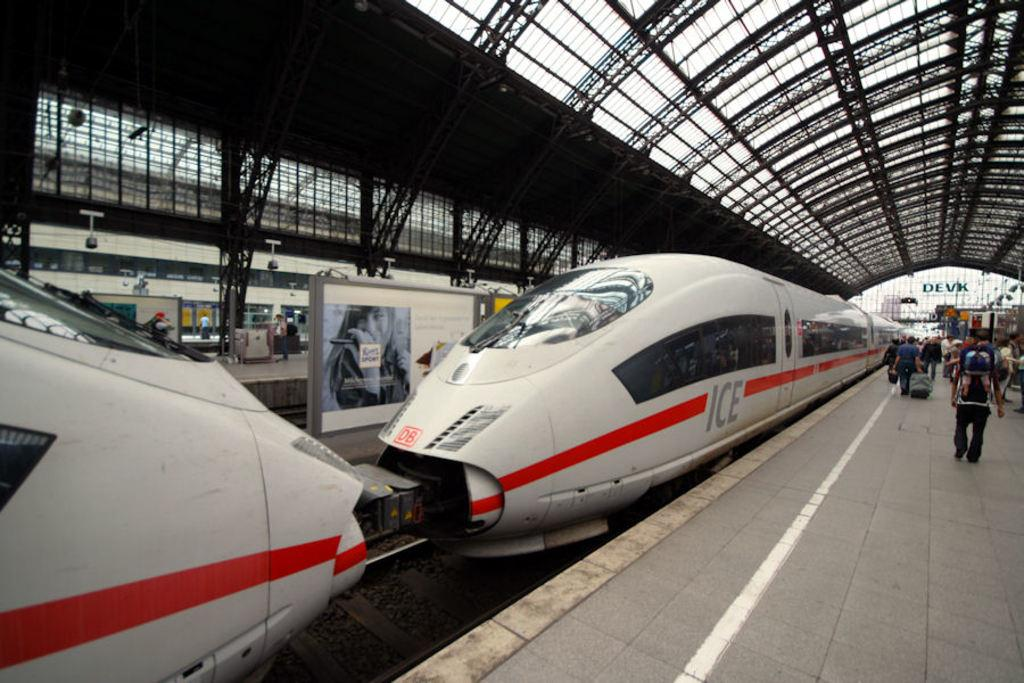<image>
Present a compact description of the photo's key features. A white bullet train that says ICE is parked in a station. 